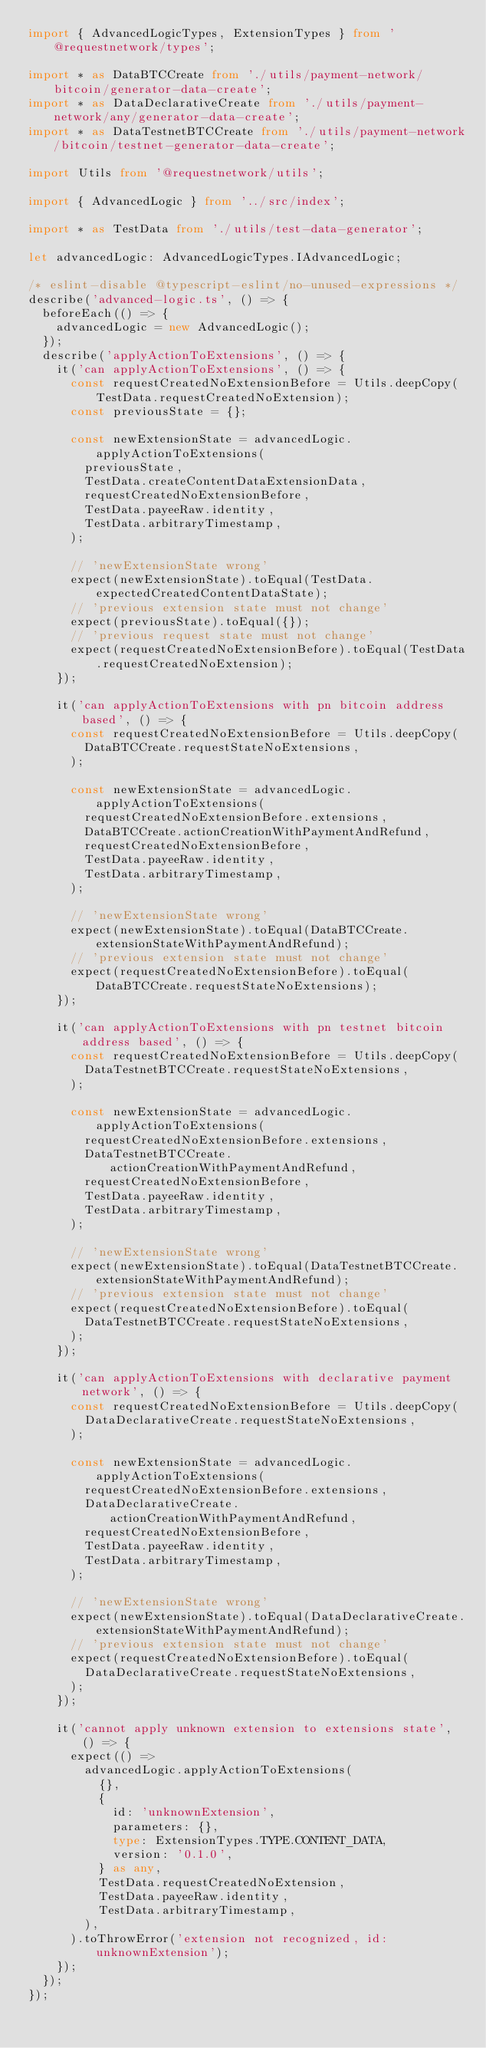<code> <loc_0><loc_0><loc_500><loc_500><_TypeScript_>import { AdvancedLogicTypes, ExtensionTypes } from '@requestnetwork/types';

import * as DataBTCCreate from './utils/payment-network/bitcoin/generator-data-create';
import * as DataDeclarativeCreate from './utils/payment-network/any/generator-data-create';
import * as DataTestnetBTCCreate from './utils/payment-network/bitcoin/testnet-generator-data-create';

import Utils from '@requestnetwork/utils';

import { AdvancedLogic } from '../src/index';

import * as TestData from './utils/test-data-generator';

let advancedLogic: AdvancedLogicTypes.IAdvancedLogic;

/* eslint-disable @typescript-eslint/no-unused-expressions */
describe('advanced-logic.ts', () => {
  beforeEach(() => {
    advancedLogic = new AdvancedLogic();
  });
  describe('applyActionToExtensions', () => {
    it('can applyActionToExtensions', () => {
      const requestCreatedNoExtensionBefore = Utils.deepCopy(TestData.requestCreatedNoExtension);
      const previousState = {};

      const newExtensionState = advancedLogic.applyActionToExtensions(
        previousState,
        TestData.createContentDataExtensionData,
        requestCreatedNoExtensionBefore,
        TestData.payeeRaw.identity,
        TestData.arbitraryTimestamp,
      );

      // 'newExtensionState wrong'
      expect(newExtensionState).toEqual(TestData.expectedCreatedContentDataState);
      // 'previous extension state must not change'
      expect(previousState).toEqual({});
      // 'previous request state must not change'
      expect(requestCreatedNoExtensionBefore).toEqual(TestData.requestCreatedNoExtension);
    });

    it('can applyActionToExtensions with pn bitcoin address based', () => {
      const requestCreatedNoExtensionBefore = Utils.deepCopy(
        DataBTCCreate.requestStateNoExtensions,
      );

      const newExtensionState = advancedLogic.applyActionToExtensions(
        requestCreatedNoExtensionBefore.extensions,
        DataBTCCreate.actionCreationWithPaymentAndRefund,
        requestCreatedNoExtensionBefore,
        TestData.payeeRaw.identity,
        TestData.arbitraryTimestamp,
      );

      // 'newExtensionState wrong'
      expect(newExtensionState).toEqual(DataBTCCreate.extensionStateWithPaymentAndRefund);
      // 'previous extension state must not change'
      expect(requestCreatedNoExtensionBefore).toEqual(DataBTCCreate.requestStateNoExtensions);
    });

    it('can applyActionToExtensions with pn testnet bitcoin address based', () => {
      const requestCreatedNoExtensionBefore = Utils.deepCopy(
        DataTestnetBTCCreate.requestStateNoExtensions,
      );

      const newExtensionState = advancedLogic.applyActionToExtensions(
        requestCreatedNoExtensionBefore.extensions,
        DataTestnetBTCCreate.actionCreationWithPaymentAndRefund,
        requestCreatedNoExtensionBefore,
        TestData.payeeRaw.identity,
        TestData.arbitraryTimestamp,
      );

      // 'newExtensionState wrong'
      expect(newExtensionState).toEqual(DataTestnetBTCCreate.extensionStateWithPaymentAndRefund);
      // 'previous extension state must not change'
      expect(requestCreatedNoExtensionBefore).toEqual(
        DataTestnetBTCCreate.requestStateNoExtensions,
      );
    });

    it('can applyActionToExtensions with declarative payment network', () => {
      const requestCreatedNoExtensionBefore = Utils.deepCopy(
        DataDeclarativeCreate.requestStateNoExtensions,
      );

      const newExtensionState = advancedLogic.applyActionToExtensions(
        requestCreatedNoExtensionBefore.extensions,
        DataDeclarativeCreate.actionCreationWithPaymentAndRefund,
        requestCreatedNoExtensionBefore,
        TestData.payeeRaw.identity,
        TestData.arbitraryTimestamp,
      );

      // 'newExtensionState wrong'
      expect(newExtensionState).toEqual(DataDeclarativeCreate.extensionStateWithPaymentAndRefund);
      // 'previous extension state must not change'
      expect(requestCreatedNoExtensionBefore).toEqual(
        DataDeclarativeCreate.requestStateNoExtensions,
      );
    });

    it('cannot apply unknown extension to extensions state', () => {
      expect(() =>
        advancedLogic.applyActionToExtensions(
          {},
          {
            id: 'unknownExtension',
            parameters: {},
            type: ExtensionTypes.TYPE.CONTENT_DATA,
            version: '0.1.0',
          } as any,
          TestData.requestCreatedNoExtension,
          TestData.payeeRaw.identity,
          TestData.arbitraryTimestamp,
        ),
      ).toThrowError('extension not recognized, id: unknownExtension');
    });
  });
});
</code> 